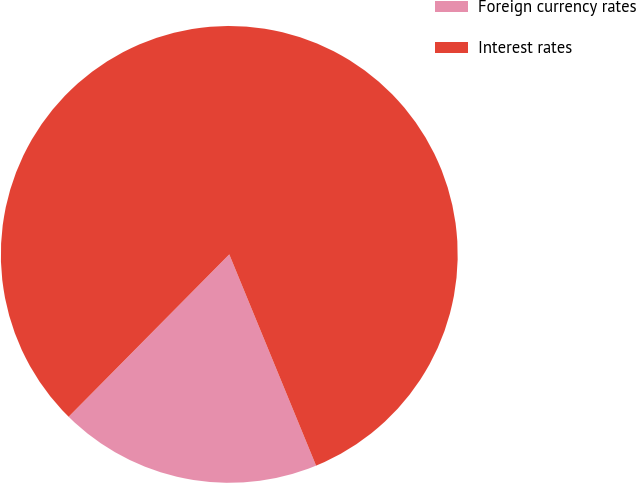<chart> <loc_0><loc_0><loc_500><loc_500><pie_chart><fcel>Foreign currency rates<fcel>Interest rates<nl><fcel>18.62%<fcel>81.38%<nl></chart> 